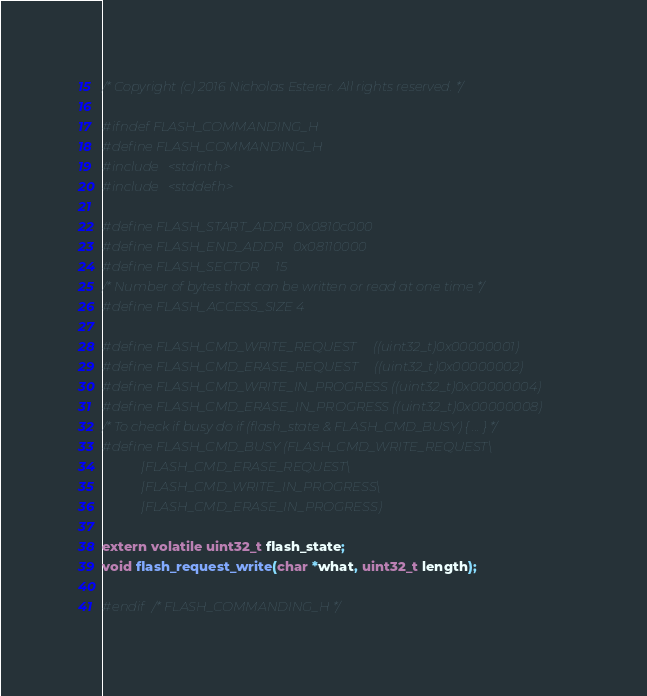Convert code to text. <code><loc_0><loc_0><loc_500><loc_500><_C_>/* Copyright (c) 2016 Nicholas Esterer. All rights reserved. */

#ifndef FLASH_COMMANDING_H
#define FLASH_COMMANDING_H 
#include <stdint.h>
#include <stddef.h> 

#define FLASH_START_ADDR 0x0810c000
#define FLASH_END_ADDR   0x08110000 
#define FLASH_SECTOR     15
/* Number of bytes that can be written or read at one time */
#define FLASH_ACCESS_SIZE 4

#define FLASH_CMD_WRITE_REQUEST     ((uint32_t)0x00000001)
#define FLASH_CMD_ERASE_REQUEST     ((uint32_t)0x00000002)
#define FLASH_CMD_WRITE_IN_PROGRESS ((uint32_t)0x00000004)
#define FLASH_CMD_ERASE_IN_PROGRESS ((uint32_t)0x00000008)
/* To check if busy do if (flash_state & FLASH_CMD_BUSY) { ... } */
#define FLASH_CMD_BUSY (FLASH_CMD_WRITE_REQUEST\
            |FLASH_CMD_ERASE_REQUEST\
            |FLASH_CMD_WRITE_IN_PROGRESS\
            |FLASH_CMD_ERASE_IN_PROGRESS)
            
extern volatile uint32_t flash_state;
void flash_request_write(char *what, uint32_t length);

#endif /* FLASH_COMMANDING_H */
</code> 